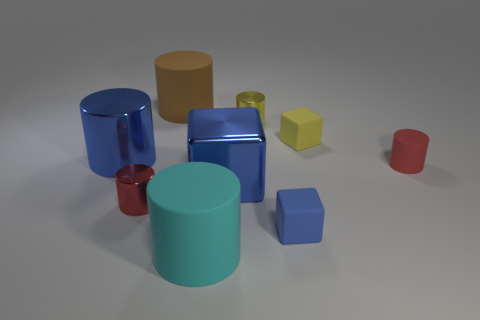How many big blocks have the same color as the tiny matte cylinder?
Your answer should be very brief. 0. What is the material of the cylinder that is the same color as the big metal cube?
Provide a succinct answer. Metal. What number of blocks are behind the small blue cube and to the right of the yellow metallic cylinder?
Your answer should be compact. 1. There is a big blue thing behind the blue metallic thing that is in front of the blue cylinder; what is its material?
Your answer should be compact. Metal. Are there any blue things made of the same material as the cyan cylinder?
Make the answer very short. Yes. What material is the cube that is the same size as the cyan matte cylinder?
Your answer should be very brief. Metal. There is a cube that is left of the yellow metallic cylinder behind the cyan rubber cylinder that is in front of the yellow cylinder; what is its size?
Your answer should be compact. Large. Are there any shiny things in front of the small yellow thing in front of the tiny yellow metallic thing?
Your answer should be compact. Yes. There is a red matte thing; is its shape the same as the blue object that is behind the metallic cube?
Provide a succinct answer. Yes. There is a tiny metal cylinder that is on the left side of the big brown thing; what color is it?
Provide a succinct answer. Red. 